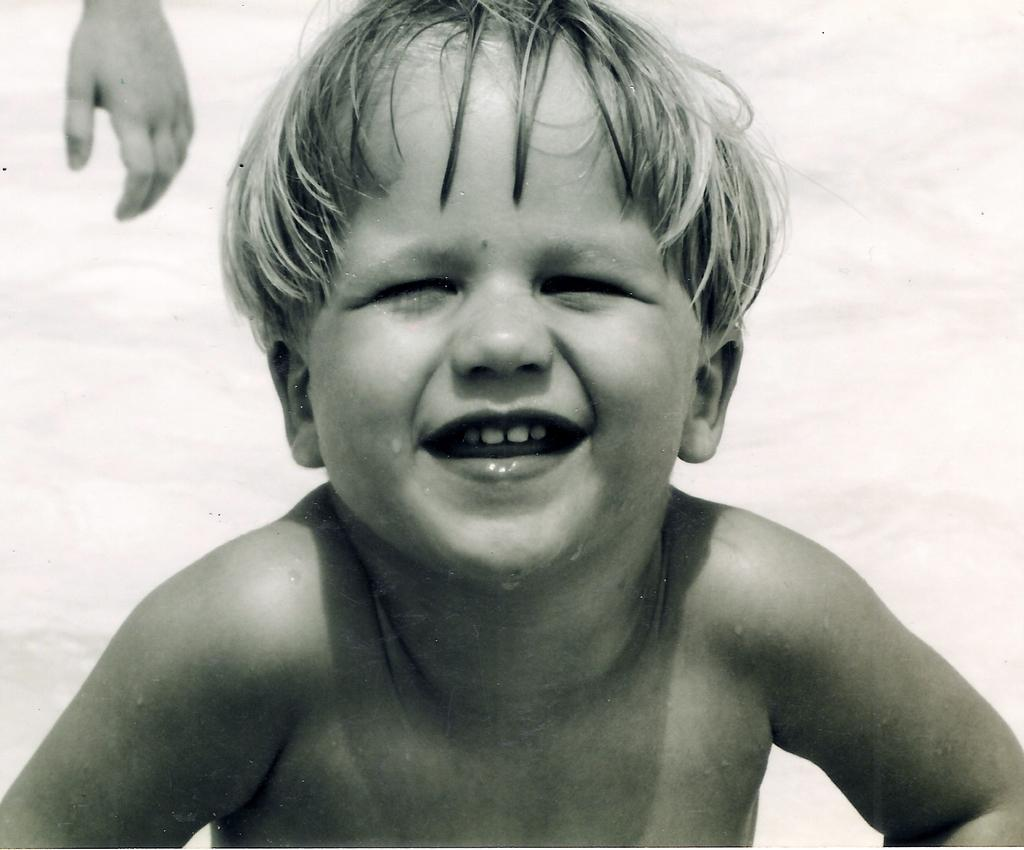What is the main subject of the picture? The main subject of the picture is a kid. Can you describe any other elements in the image? Yes, there is a person's hand visible in the picture. What type of country is depicted in the background of the image? There is no country visible in the image; it only features a kid and a person's hand. How many ladybugs can be seen on the kid's shirt in the image? There are no ladybugs present in the image. 